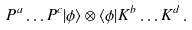Convert formula to latex. <formula><loc_0><loc_0><loc_500><loc_500>P ^ { a } \dots P ^ { c } | \phi \rangle \otimes \langle \phi | K ^ { b } \dots K ^ { d } \, .</formula> 